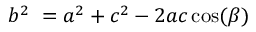<formula> <loc_0><loc_0><loc_500><loc_500>b ^ { 2 } \ = a ^ { 2 } + c ^ { 2 } - 2 a c \cos ( \beta )</formula> 